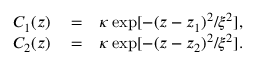Convert formula to latex. <formula><loc_0><loc_0><loc_500><loc_500>\begin{array} { r } { \begin{array} { r l r } { C _ { 1 } ( z ) } & = } & { \kappa \exp [ - ( z - z _ { 1 } ) ^ { 2 } / \xi ^ { 2 } ] , } \\ { C _ { 2 } ( z ) } & = } & { \kappa \exp [ - ( z - z _ { 2 } ) ^ { 2 } / \xi ^ { 2 } ] . } \end{array} } \end{array}</formula> 